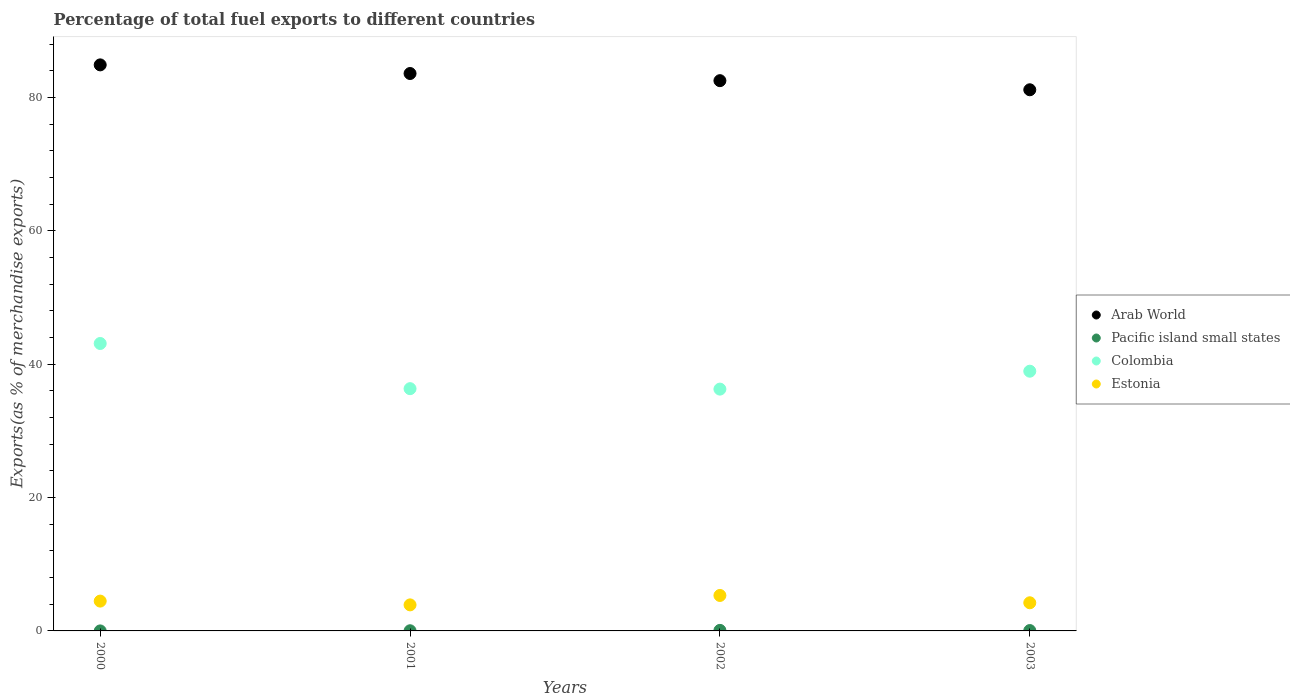What is the percentage of exports to different countries in Colombia in 2000?
Your response must be concise. 43.11. Across all years, what is the maximum percentage of exports to different countries in Arab World?
Provide a short and direct response. 84.9. Across all years, what is the minimum percentage of exports to different countries in Estonia?
Provide a short and direct response. 3.91. In which year was the percentage of exports to different countries in Arab World maximum?
Offer a very short reply. 2000. What is the total percentage of exports to different countries in Pacific island small states in the graph?
Your response must be concise. 0.16. What is the difference between the percentage of exports to different countries in Pacific island small states in 2001 and that in 2003?
Make the answer very short. -0.03. What is the difference between the percentage of exports to different countries in Colombia in 2003 and the percentage of exports to different countries in Arab World in 2001?
Ensure brevity in your answer.  -44.65. What is the average percentage of exports to different countries in Colombia per year?
Offer a terse response. 38.67. In the year 2003, what is the difference between the percentage of exports to different countries in Colombia and percentage of exports to different countries in Arab World?
Provide a short and direct response. -42.21. In how many years, is the percentage of exports to different countries in Estonia greater than 44 %?
Offer a terse response. 0. What is the ratio of the percentage of exports to different countries in Estonia in 2001 to that in 2003?
Make the answer very short. 0.93. What is the difference between the highest and the second highest percentage of exports to different countries in Pacific island small states?
Your response must be concise. 0.03. What is the difference between the highest and the lowest percentage of exports to different countries in Arab World?
Give a very brief answer. 3.73. Is it the case that in every year, the sum of the percentage of exports to different countries in Pacific island small states and percentage of exports to different countries in Arab World  is greater than the sum of percentage of exports to different countries in Estonia and percentage of exports to different countries in Colombia?
Provide a short and direct response. No. Is it the case that in every year, the sum of the percentage of exports to different countries in Colombia and percentage of exports to different countries in Pacific island small states  is greater than the percentage of exports to different countries in Estonia?
Ensure brevity in your answer.  Yes. Is the percentage of exports to different countries in Arab World strictly greater than the percentage of exports to different countries in Pacific island small states over the years?
Make the answer very short. Yes. How many dotlines are there?
Your answer should be compact. 4. How many years are there in the graph?
Provide a succinct answer. 4. What is the difference between two consecutive major ticks on the Y-axis?
Offer a very short reply. 20. Does the graph contain any zero values?
Provide a succinct answer. No. Does the graph contain grids?
Offer a very short reply. No. How many legend labels are there?
Make the answer very short. 4. What is the title of the graph?
Provide a succinct answer. Percentage of total fuel exports to different countries. Does "Austria" appear as one of the legend labels in the graph?
Keep it short and to the point. No. What is the label or title of the Y-axis?
Provide a short and direct response. Exports(as % of merchandise exports). What is the Exports(as % of merchandise exports) in Arab World in 2000?
Your response must be concise. 84.9. What is the Exports(as % of merchandise exports) of Pacific island small states in 2000?
Offer a terse response. 0. What is the Exports(as % of merchandise exports) in Colombia in 2000?
Offer a very short reply. 43.11. What is the Exports(as % of merchandise exports) in Estonia in 2000?
Make the answer very short. 4.47. What is the Exports(as % of merchandise exports) in Arab World in 2001?
Give a very brief answer. 83.6. What is the Exports(as % of merchandise exports) of Pacific island small states in 2001?
Provide a succinct answer. 0.02. What is the Exports(as % of merchandise exports) of Colombia in 2001?
Offer a terse response. 36.33. What is the Exports(as % of merchandise exports) of Estonia in 2001?
Keep it short and to the point. 3.91. What is the Exports(as % of merchandise exports) of Arab World in 2002?
Ensure brevity in your answer.  82.53. What is the Exports(as % of merchandise exports) in Pacific island small states in 2002?
Make the answer very short. 0.08. What is the Exports(as % of merchandise exports) of Colombia in 2002?
Your response must be concise. 36.27. What is the Exports(as % of merchandise exports) in Estonia in 2002?
Keep it short and to the point. 5.32. What is the Exports(as % of merchandise exports) of Arab World in 2003?
Offer a terse response. 81.16. What is the Exports(as % of merchandise exports) in Pacific island small states in 2003?
Your answer should be very brief. 0.05. What is the Exports(as % of merchandise exports) in Colombia in 2003?
Offer a very short reply. 38.95. What is the Exports(as % of merchandise exports) of Estonia in 2003?
Offer a terse response. 4.22. Across all years, what is the maximum Exports(as % of merchandise exports) of Arab World?
Give a very brief answer. 84.9. Across all years, what is the maximum Exports(as % of merchandise exports) in Pacific island small states?
Your answer should be compact. 0.08. Across all years, what is the maximum Exports(as % of merchandise exports) of Colombia?
Your answer should be very brief. 43.11. Across all years, what is the maximum Exports(as % of merchandise exports) of Estonia?
Offer a very short reply. 5.32. Across all years, what is the minimum Exports(as % of merchandise exports) of Arab World?
Make the answer very short. 81.16. Across all years, what is the minimum Exports(as % of merchandise exports) in Pacific island small states?
Offer a terse response. 0. Across all years, what is the minimum Exports(as % of merchandise exports) in Colombia?
Your answer should be very brief. 36.27. Across all years, what is the minimum Exports(as % of merchandise exports) in Estonia?
Keep it short and to the point. 3.91. What is the total Exports(as % of merchandise exports) of Arab World in the graph?
Make the answer very short. 332.19. What is the total Exports(as % of merchandise exports) of Pacific island small states in the graph?
Your answer should be very brief. 0.16. What is the total Exports(as % of merchandise exports) of Colombia in the graph?
Offer a terse response. 154.66. What is the total Exports(as % of merchandise exports) in Estonia in the graph?
Your answer should be compact. 17.92. What is the difference between the Exports(as % of merchandise exports) of Arab World in 2000 and that in 2001?
Your response must be concise. 1.29. What is the difference between the Exports(as % of merchandise exports) of Pacific island small states in 2000 and that in 2001?
Offer a very short reply. -0.02. What is the difference between the Exports(as % of merchandise exports) in Colombia in 2000 and that in 2001?
Provide a succinct answer. 6.78. What is the difference between the Exports(as % of merchandise exports) in Estonia in 2000 and that in 2001?
Ensure brevity in your answer.  0.57. What is the difference between the Exports(as % of merchandise exports) in Arab World in 2000 and that in 2002?
Your response must be concise. 2.37. What is the difference between the Exports(as % of merchandise exports) of Pacific island small states in 2000 and that in 2002?
Ensure brevity in your answer.  -0.08. What is the difference between the Exports(as % of merchandise exports) in Colombia in 2000 and that in 2002?
Make the answer very short. 6.84. What is the difference between the Exports(as % of merchandise exports) of Estonia in 2000 and that in 2002?
Keep it short and to the point. -0.85. What is the difference between the Exports(as % of merchandise exports) of Arab World in 2000 and that in 2003?
Make the answer very short. 3.73. What is the difference between the Exports(as % of merchandise exports) in Pacific island small states in 2000 and that in 2003?
Ensure brevity in your answer.  -0.05. What is the difference between the Exports(as % of merchandise exports) in Colombia in 2000 and that in 2003?
Your response must be concise. 4.16. What is the difference between the Exports(as % of merchandise exports) of Estonia in 2000 and that in 2003?
Your answer should be compact. 0.25. What is the difference between the Exports(as % of merchandise exports) of Arab World in 2001 and that in 2002?
Your answer should be compact. 1.07. What is the difference between the Exports(as % of merchandise exports) of Pacific island small states in 2001 and that in 2002?
Offer a terse response. -0.06. What is the difference between the Exports(as % of merchandise exports) of Colombia in 2001 and that in 2002?
Your answer should be very brief. 0.07. What is the difference between the Exports(as % of merchandise exports) in Estonia in 2001 and that in 2002?
Offer a very short reply. -1.41. What is the difference between the Exports(as % of merchandise exports) of Arab World in 2001 and that in 2003?
Ensure brevity in your answer.  2.44. What is the difference between the Exports(as % of merchandise exports) in Pacific island small states in 2001 and that in 2003?
Your answer should be very brief. -0.03. What is the difference between the Exports(as % of merchandise exports) of Colombia in 2001 and that in 2003?
Provide a short and direct response. -2.62. What is the difference between the Exports(as % of merchandise exports) in Estonia in 2001 and that in 2003?
Offer a terse response. -0.31. What is the difference between the Exports(as % of merchandise exports) in Arab World in 2002 and that in 2003?
Keep it short and to the point. 1.37. What is the difference between the Exports(as % of merchandise exports) of Pacific island small states in 2002 and that in 2003?
Make the answer very short. 0.03. What is the difference between the Exports(as % of merchandise exports) in Colombia in 2002 and that in 2003?
Give a very brief answer. -2.69. What is the difference between the Exports(as % of merchandise exports) in Estonia in 2002 and that in 2003?
Offer a terse response. 1.1. What is the difference between the Exports(as % of merchandise exports) in Arab World in 2000 and the Exports(as % of merchandise exports) in Pacific island small states in 2001?
Provide a succinct answer. 84.87. What is the difference between the Exports(as % of merchandise exports) of Arab World in 2000 and the Exports(as % of merchandise exports) of Colombia in 2001?
Keep it short and to the point. 48.56. What is the difference between the Exports(as % of merchandise exports) of Arab World in 2000 and the Exports(as % of merchandise exports) of Estonia in 2001?
Provide a succinct answer. 80.99. What is the difference between the Exports(as % of merchandise exports) in Pacific island small states in 2000 and the Exports(as % of merchandise exports) in Colombia in 2001?
Your response must be concise. -36.33. What is the difference between the Exports(as % of merchandise exports) in Pacific island small states in 2000 and the Exports(as % of merchandise exports) in Estonia in 2001?
Your answer should be compact. -3.91. What is the difference between the Exports(as % of merchandise exports) of Colombia in 2000 and the Exports(as % of merchandise exports) of Estonia in 2001?
Keep it short and to the point. 39.2. What is the difference between the Exports(as % of merchandise exports) of Arab World in 2000 and the Exports(as % of merchandise exports) of Pacific island small states in 2002?
Provide a succinct answer. 84.82. What is the difference between the Exports(as % of merchandise exports) of Arab World in 2000 and the Exports(as % of merchandise exports) of Colombia in 2002?
Make the answer very short. 48.63. What is the difference between the Exports(as % of merchandise exports) in Arab World in 2000 and the Exports(as % of merchandise exports) in Estonia in 2002?
Make the answer very short. 79.58. What is the difference between the Exports(as % of merchandise exports) of Pacific island small states in 2000 and the Exports(as % of merchandise exports) of Colombia in 2002?
Provide a succinct answer. -36.27. What is the difference between the Exports(as % of merchandise exports) in Pacific island small states in 2000 and the Exports(as % of merchandise exports) in Estonia in 2002?
Keep it short and to the point. -5.32. What is the difference between the Exports(as % of merchandise exports) of Colombia in 2000 and the Exports(as % of merchandise exports) of Estonia in 2002?
Your response must be concise. 37.79. What is the difference between the Exports(as % of merchandise exports) of Arab World in 2000 and the Exports(as % of merchandise exports) of Pacific island small states in 2003?
Provide a short and direct response. 84.84. What is the difference between the Exports(as % of merchandise exports) in Arab World in 2000 and the Exports(as % of merchandise exports) in Colombia in 2003?
Your answer should be compact. 45.94. What is the difference between the Exports(as % of merchandise exports) of Arab World in 2000 and the Exports(as % of merchandise exports) of Estonia in 2003?
Provide a succinct answer. 80.68. What is the difference between the Exports(as % of merchandise exports) in Pacific island small states in 2000 and the Exports(as % of merchandise exports) in Colombia in 2003?
Your response must be concise. -38.95. What is the difference between the Exports(as % of merchandise exports) of Pacific island small states in 2000 and the Exports(as % of merchandise exports) of Estonia in 2003?
Provide a succinct answer. -4.22. What is the difference between the Exports(as % of merchandise exports) of Colombia in 2000 and the Exports(as % of merchandise exports) of Estonia in 2003?
Ensure brevity in your answer.  38.89. What is the difference between the Exports(as % of merchandise exports) in Arab World in 2001 and the Exports(as % of merchandise exports) in Pacific island small states in 2002?
Ensure brevity in your answer.  83.52. What is the difference between the Exports(as % of merchandise exports) of Arab World in 2001 and the Exports(as % of merchandise exports) of Colombia in 2002?
Keep it short and to the point. 47.34. What is the difference between the Exports(as % of merchandise exports) of Arab World in 2001 and the Exports(as % of merchandise exports) of Estonia in 2002?
Your answer should be compact. 78.28. What is the difference between the Exports(as % of merchandise exports) in Pacific island small states in 2001 and the Exports(as % of merchandise exports) in Colombia in 2002?
Offer a very short reply. -36.24. What is the difference between the Exports(as % of merchandise exports) of Pacific island small states in 2001 and the Exports(as % of merchandise exports) of Estonia in 2002?
Your answer should be compact. -5.29. What is the difference between the Exports(as % of merchandise exports) of Colombia in 2001 and the Exports(as % of merchandise exports) of Estonia in 2002?
Your answer should be compact. 31.02. What is the difference between the Exports(as % of merchandise exports) of Arab World in 2001 and the Exports(as % of merchandise exports) of Pacific island small states in 2003?
Ensure brevity in your answer.  83.55. What is the difference between the Exports(as % of merchandise exports) in Arab World in 2001 and the Exports(as % of merchandise exports) in Colombia in 2003?
Make the answer very short. 44.65. What is the difference between the Exports(as % of merchandise exports) of Arab World in 2001 and the Exports(as % of merchandise exports) of Estonia in 2003?
Your answer should be very brief. 79.38. What is the difference between the Exports(as % of merchandise exports) of Pacific island small states in 2001 and the Exports(as % of merchandise exports) of Colombia in 2003?
Offer a very short reply. -38.93. What is the difference between the Exports(as % of merchandise exports) in Pacific island small states in 2001 and the Exports(as % of merchandise exports) in Estonia in 2003?
Provide a succinct answer. -4.2. What is the difference between the Exports(as % of merchandise exports) of Colombia in 2001 and the Exports(as % of merchandise exports) of Estonia in 2003?
Your answer should be very brief. 32.11. What is the difference between the Exports(as % of merchandise exports) in Arab World in 2002 and the Exports(as % of merchandise exports) in Pacific island small states in 2003?
Offer a very short reply. 82.47. What is the difference between the Exports(as % of merchandise exports) of Arab World in 2002 and the Exports(as % of merchandise exports) of Colombia in 2003?
Provide a short and direct response. 43.58. What is the difference between the Exports(as % of merchandise exports) of Arab World in 2002 and the Exports(as % of merchandise exports) of Estonia in 2003?
Your answer should be very brief. 78.31. What is the difference between the Exports(as % of merchandise exports) of Pacific island small states in 2002 and the Exports(as % of merchandise exports) of Colombia in 2003?
Offer a terse response. -38.87. What is the difference between the Exports(as % of merchandise exports) of Pacific island small states in 2002 and the Exports(as % of merchandise exports) of Estonia in 2003?
Offer a very short reply. -4.14. What is the difference between the Exports(as % of merchandise exports) of Colombia in 2002 and the Exports(as % of merchandise exports) of Estonia in 2003?
Your response must be concise. 32.05. What is the average Exports(as % of merchandise exports) in Arab World per year?
Make the answer very short. 83.05. What is the average Exports(as % of merchandise exports) of Pacific island small states per year?
Offer a very short reply. 0.04. What is the average Exports(as % of merchandise exports) in Colombia per year?
Make the answer very short. 38.67. What is the average Exports(as % of merchandise exports) of Estonia per year?
Make the answer very short. 4.48. In the year 2000, what is the difference between the Exports(as % of merchandise exports) of Arab World and Exports(as % of merchandise exports) of Pacific island small states?
Provide a succinct answer. 84.9. In the year 2000, what is the difference between the Exports(as % of merchandise exports) in Arab World and Exports(as % of merchandise exports) in Colombia?
Your answer should be compact. 41.79. In the year 2000, what is the difference between the Exports(as % of merchandise exports) in Arab World and Exports(as % of merchandise exports) in Estonia?
Provide a succinct answer. 80.42. In the year 2000, what is the difference between the Exports(as % of merchandise exports) of Pacific island small states and Exports(as % of merchandise exports) of Colombia?
Offer a terse response. -43.11. In the year 2000, what is the difference between the Exports(as % of merchandise exports) of Pacific island small states and Exports(as % of merchandise exports) of Estonia?
Your response must be concise. -4.47. In the year 2000, what is the difference between the Exports(as % of merchandise exports) of Colombia and Exports(as % of merchandise exports) of Estonia?
Make the answer very short. 38.64. In the year 2001, what is the difference between the Exports(as % of merchandise exports) in Arab World and Exports(as % of merchandise exports) in Pacific island small states?
Offer a terse response. 83.58. In the year 2001, what is the difference between the Exports(as % of merchandise exports) of Arab World and Exports(as % of merchandise exports) of Colombia?
Make the answer very short. 47.27. In the year 2001, what is the difference between the Exports(as % of merchandise exports) in Arab World and Exports(as % of merchandise exports) in Estonia?
Give a very brief answer. 79.7. In the year 2001, what is the difference between the Exports(as % of merchandise exports) in Pacific island small states and Exports(as % of merchandise exports) in Colombia?
Make the answer very short. -36.31. In the year 2001, what is the difference between the Exports(as % of merchandise exports) in Pacific island small states and Exports(as % of merchandise exports) in Estonia?
Ensure brevity in your answer.  -3.88. In the year 2001, what is the difference between the Exports(as % of merchandise exports) in Colombia and Exports(as % of merchandise exports) in Estonia?
Your response must be concise. 32.43. In the year 2002, what is the difference between the Exports(as % of merchandise exports) of Arab World and Exports(as % of merchandise exports) of Pacific island small states?
Your answer should be compact. 82.45. In the year 2002, what is the difference between the Exports(as % of merchandise exports) in Arab World and Exports(as % of merchandise exports) in Colombia?
Make the answer very short. 46.26. In the year 2002, what is the difference between the Exports(as % of merchandise exports) in Arab World and Exports(as % of merchandise exports) in Estonia?
Your response must be concise. 77.21. In the year 2002, what is the difference between the Exports(as % of merchandise exports) of Pacific island small states and Exports(as % of merchandise exports) of Colombia?
Your answer should be compact. -36.18. In the year 2002, what is the difference between the Exports(as % of merchandise exports) in Pacific island small states and Exports(as % of merchandise exports) in Estonia?
Give a very brief answer. -5.24. In the year 2002, what is the difference between the Exports(as % of merchandise exports) in Colombia and Exports(as % of merchandise exports) in Estonia?
Your answer should be very brief. 30.95. In the year 2003, what is the difference between the Exports(as % of merchandise exports) in Arab World and Exports(as % of merchandise exports) in Pacific island small states?
Your answer should be very brief. 81.11. In the year 2003, what is the difference between the Exports(as % of merchandise exports) of Arab World and Exports(as % of merchandise exports) of Colombia?
Your response must be concise. 42.21. In the year 2003, what is the difference between the Exports(as % of merchandise exports) of Arab World and Exports(as % of merchandise exports) of Estonia?
Offer a very short reply. 76.94. In the year 2003, what is the difference between the Exports(as % of merchandise exports) of Pacific island small states and Exports(as % of merchandise exports) of Colombia?
Provide a short and direct response. -38.9. In the year 2003, what is the difference between the Exports(as % of merchandise exports) of Pacific island small states and Exports(as % of merchandise exports) of Estonia?
Give a very brief answer. -4.17. In the year 2003, what is the difference between the Exports(as % of merchandise exports) of Colombia and Exports(as % of merchandise exports) of Estonia?
Offer a very short reply. 34.73. What is the ratio of the Exports(as % of merchandise exports) in Arab World in 2000 to that in 2001?
Give a very brief answer. 1.02. What is the ratio of the Exports(as % of merchandise exports) in Pacific island small states in 2000 to that in 2001?
Offer a very short reply. 0.05. What is the ratio of the Exports(as % of merchandise exports) of Colombia in 2000 to that in 2001?
Provide a short and direct response. 1.19. What is the ratio of the Exports(as % of merchandise exports) of Estonia in 2000 to that in 2001?
Provide a succinct answer. 1.14. What is the ratio of the Exports(as % of merchandise exports) of Arab World in 2000 to that in 2002?
Your answer should be compact. 1.03. What is the ratio of the Exports(as % of merchandise exports) of Pacific island small states in 2000 to that in 2002?
Your response must be concise. 0.02. What is the ratio of the Exports(as % of merchandise exports) of Colombia in 2000 to that in 2002?
Make the answer very short. 1.19. What is the ratio of the Exports(as % of merchandise exports) in Estonia in 2000 to that in 2002?
Offer a terse response. 0.84. What is the ratio of the Exports(as % of merchandise exports) in Arab World in 2000 to that in 2003?
Provide a short and direct response. 1.05. What is the ratio of the Exports(as % of merchandise exports) in Pacific island small states in 2000 to that in 2003?
Give a very brief answer. 0.02. What is the ratio of the Exports(as % of merchandise exports) of Colombia in 2000 to that in 2003?
Your answer should be compact. 1.11. What is the ratio of the Exports(as % of merchandise exports) in Estonia in 2000 to that in 2003?
Ensure brevity in your answer.  1.06. What is the ratio of the Exports(as % of merchandise exports) of Pacific island small states in 2001 to that in 2002?
Offer a terse response. 0.3. What is the ratio of the Exports(as % of merchandise exports) of Colombia in 2001 to that in 2002?
Make the answer very short. 1. What is the ratio of the Exports(as % of merchandise exports) in Estonia in 2001 to that in 2002?
Your answer should be very brief. 0.73. What is the ratio of the Exports(as % of merchandise exports) of Arab World in 2001 to that in 2003?
Make the answer very short. 1.03. What is the ratio of the Exports(as % of merchandise exports) in Pacific island small states in 2001 to that in 2003?
Make the answer very short. 0.45. What is the ratio of the Exports(as % of merchandise exports) of Colombia in 2001 to that in 2003?
Make the answer very short. 0.93. What is the ratio of the Exports(as % of merchandise exports) of Estonia in 2001 to that in 2003?
Give a very brief answer. 0.93. What is the ratio of the Exports(as % of merchandise exports) of Arab World in 2002 to that in 2003?
Your answer should be very brief. 1.02. What is the ratio of the Exports(as % of merchandise exports) in Pacific island small states in 2002 to that in 2003?
Provide a succinct answer. 1.5. What is the ratio of the Exports(as % of merchandise exports) of Estonia in 2002 to that in 2003?
Keep it short and to the point. 1.26. What is the difference between the highest and the second highest Exports(as % of merchandise exports) in Arab World?
Offer a very short reply. 1.29. What is the difference between the highest and the second highest Exports(as % of merchandise exports) in Pacific island small states?
Make the answer very short. 0.03. What is the difference between the highest and the second highest Exports(as % of merchandise exports) of Colombia?
Offer a very short reply. 4.16. What is the difference between the highest and the second highest Exports(as % of merchandise exports) in Estonia?
Give a very brief answer. 0.85. What is the difference between the highest and the lowest Exports(as % of merchandise exports) of Arab World?
Provide a succinct answer. 3.73. What is the difference between the highest and the lowest Exports(as % of merchandise exports) of Pacific island small states?
Your response must be concise. 0.08. What is the difference between the highest and the lowest Exports(as % of merchandise exports) of Colombia?
Make the answer very short. 6.84. What is the difference between the highest and the lowest Exports(as % of merchandise exports) of Estonia?
Your answer should be very brief. 1.41. 